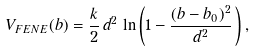<formula> <loc_0><loc_0><loc_500><loc_500>V _ { F E N E } ( b ) = \frac { k } { 2 } \, d ^ { 2 } \, \ln \left ( 1 - \frac { ( b - b _ { 0 } ) ^ { 2 } } { d ^ { 2 } } \, \right ) ,</formula> 